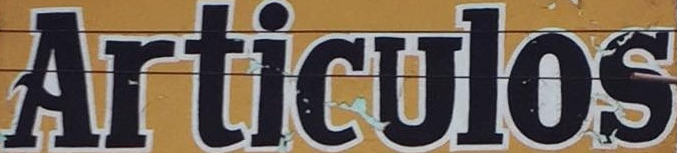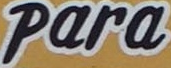Read the text content from these images in order, separated by a semicolon. Articulos; Para 